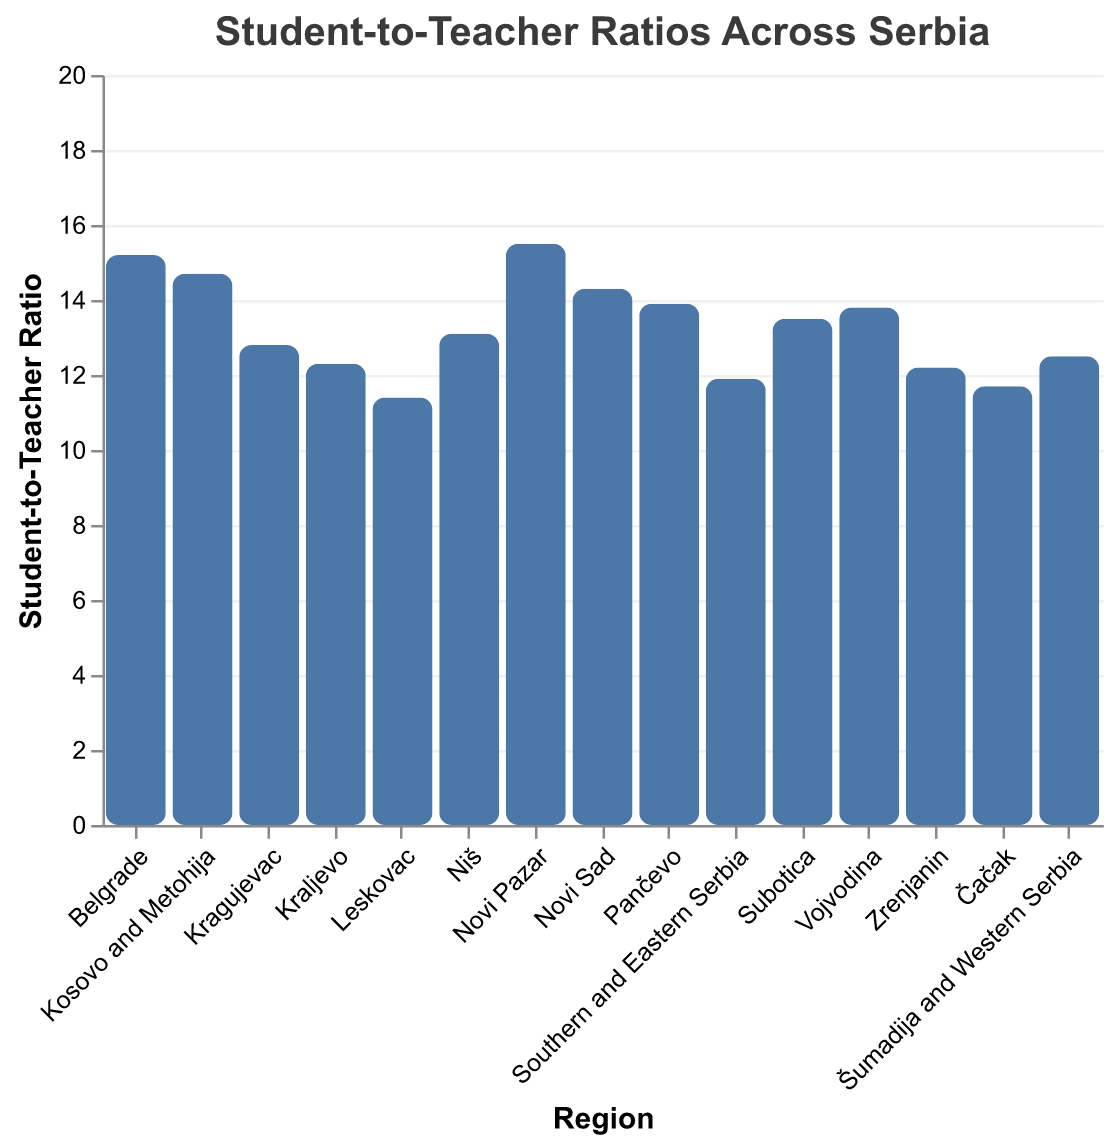what is the highest student-to-teacher ratio among the regions? The highest student-to-teacher ratio can be identified by looking at the tallest bar in the bar plot. The tallest bar represents Novi Pazar with a ratio of 15.5.
Answer: Novi Pazar, 15.5 What is the median student-to-teacher ratio across all regions? To find the median value, first list all ratios in ascending order: 11.4, 11.7, 11.9, 12.2, 12.3, 12.5, 12.8, 13.1, 13.5, 13.8, 13.9, 14.3, 14.7, 15.2, 15.5. The middle value of this ordered list is the median, which is 13.1.
Answer: 13.1 Which region has the lowest student-to-teacher ratio? The region with the lowest student-to-teacher ratio can be identified by looking at the shortest bar in the bar plot. The shortest bar represents Leskovac with a ratio of 11.4.
Answer: Leskovac, 11.4 How many regions have a student-to-teacher ratio higher than 14? By scanning the bars, the regions with ratios higher than 14 are Belgrade, Kosovo and Metohija, Novi Sad, and Novi Pazar.
Answer: 4 What is the difference in student-to-teacher ratio between the region with the highest ratio and the region with the lowest ratio? The highest ratio is 15.5 (Novi Pazar) and the lowest ratio is 11.4 (Leskovac). The difference is 15.5 - 11.4.
Answer: 4.1 Which regions have a student-to-teacher ratio between 13 and 14? By examining the plot, the regions fitting this range are Vojvodina (13.8), Niš (13.1), Subotica (13.5), and Pančevo (13.9).
Answer: Vojvodina, Niš, Subotica, Pančevo Which region has a student-to-teacher ratio closest to the average ratio across all regions? First, compute the average ratio by summing all ratios and dividing by the number of regions: (11.4 + 11.7 + 11.9 + 12.2 + 12.3 + 12.5 + 12.8 + 13.1 + 13.5 + 13.8 + 13.9 + 14.3 + 14.7 + 15.2 + 15.5) / 15 = 13.1. The region closest to the average is Niš which has a ratio of 13.1.
Answer: Niš What is the combined student-to-teacher ratio of Belgrade, Vojvodina, and Novi Pazar? Add the ratios of Belgrade (15.2), Vojvodina (13.8), and Novi Pazar (15.5): 15.2 + 13.8 + 15.5 = 44.5.
Answer: 44.5 